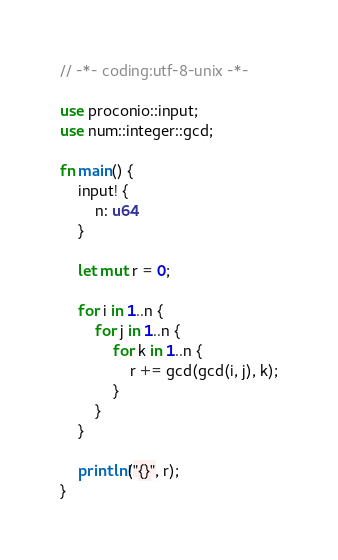<code> <loc_0><loc_0><loc_500><loc_500><_Rust_>// -*- coding:utf-8-unix -*-

use proconio::input;
use num::integer::gcd;

fn main() {
    input! {
        n: u64
    }

    let mut r = 0;

    for i in 1..n {
        for j in 1..n {
            for k in 1..n {
                r += gcd(gcd(i, j), k);
            }
        }
    }

    println!("{}", r);
}
</code> 